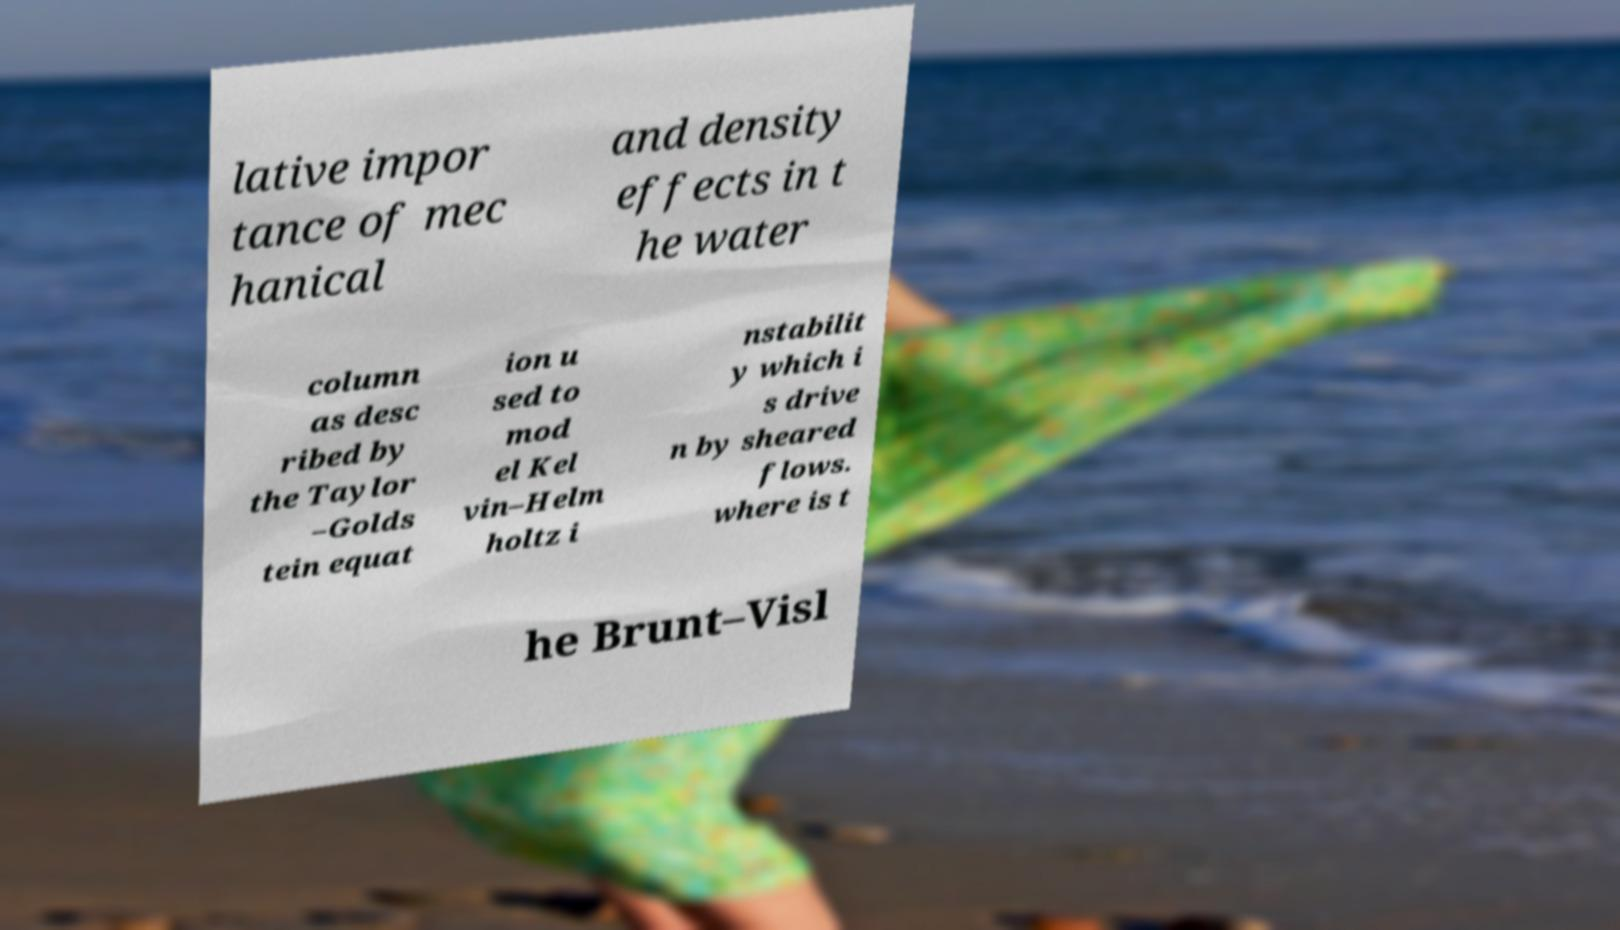Can you accurately transcribe the text from the provided image for me? lative impor tance of mec hanical and density effects in t he water column as desc ribed by the Taylor –Golds tein equat ion u sed to mod el Kel vin–Helm holtz i nstabilit y which i s drive n by sheared flows. where is t he Brunt–Visl 